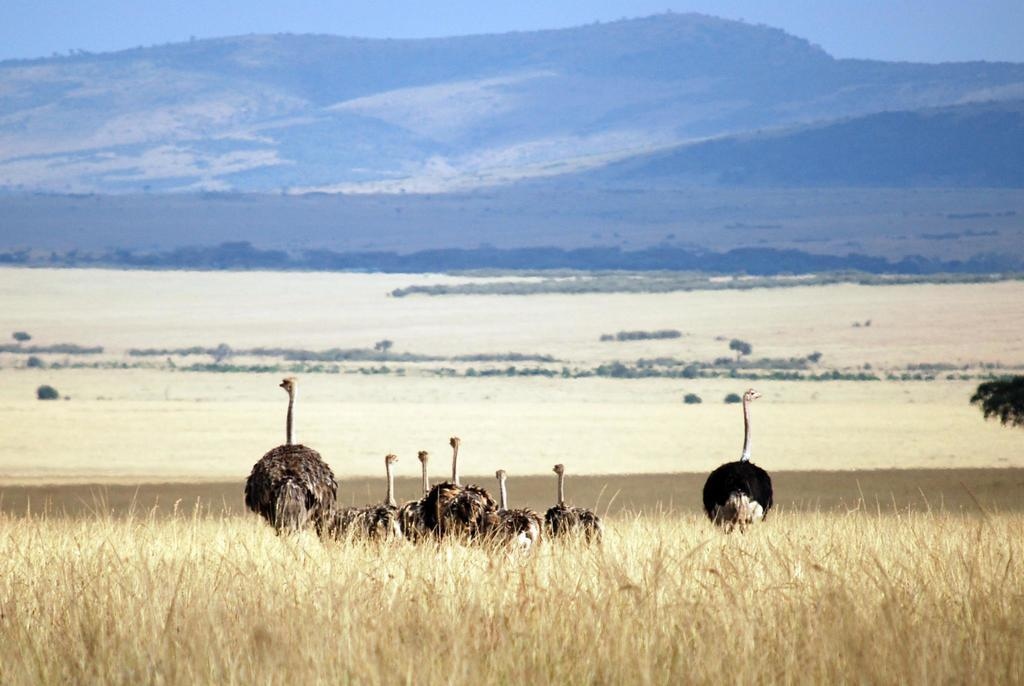What type of animals are standing in the image? There are ostriches standing in the image. What type of vegetation is visible in the background of the image? There is grass visible in the background of the image. What other natural elements can be seen in the background of the image? There are trees and hills visible in the background of the image. What part of the natural environment is visible in the background of the image? The sky is visible in the background of the image. What type of police vehicle can be seen in the image? There is no police vehicle present in the image. What type of sport is being played in the image? There is no sport being played in the image. What type of snack is visible in the image? There is no snack visible in the image. 